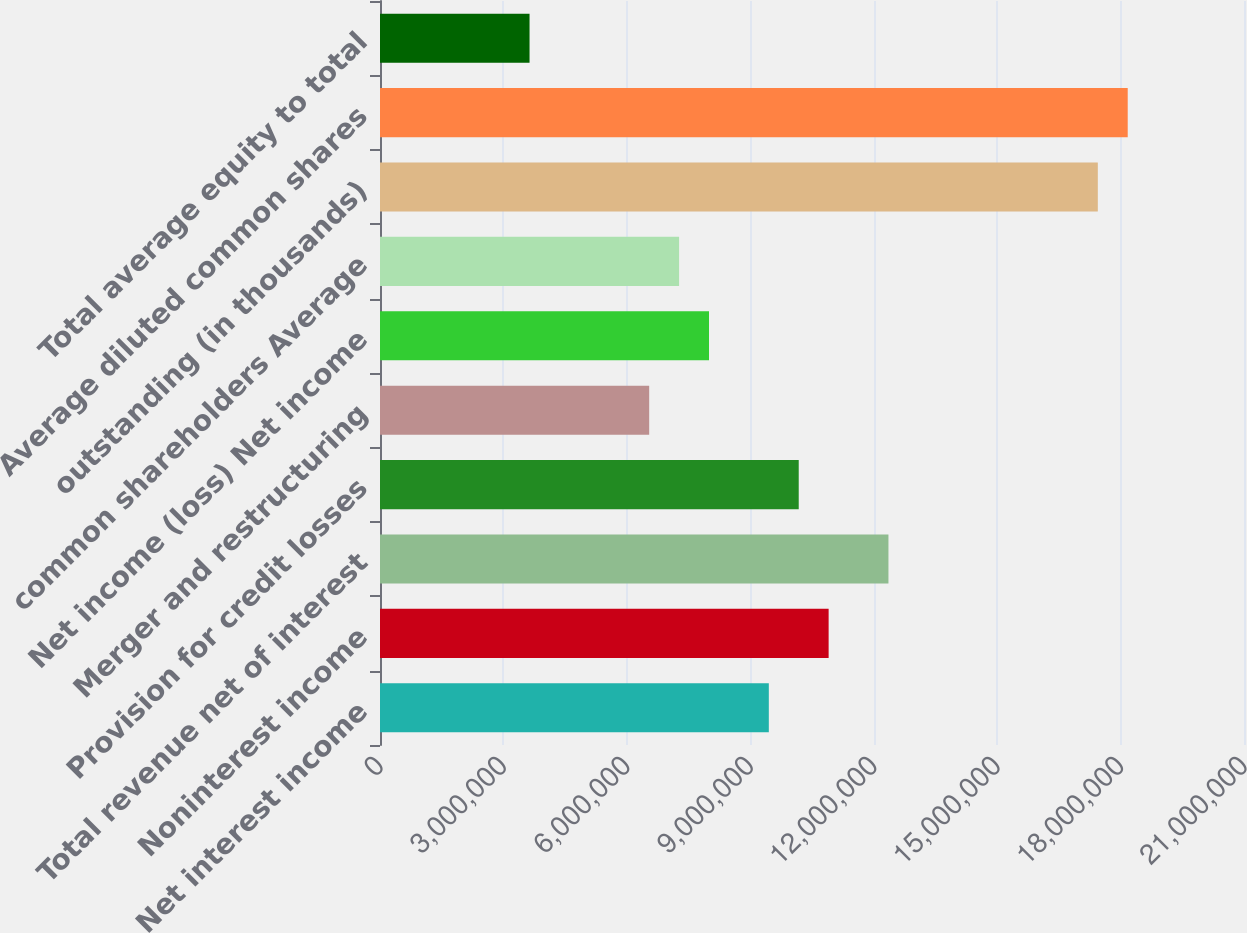<chart> <loc_0><loc_0><loc_500><loc_500><bar_chart><fcel>Net interest income<fcel>Noninterest income<fcel>Total revenue net of interest<fcel>Provision for credit losses<fcel>Merger and restructuring<fcel>Net income (loss) Net income<fcel>common shareholders Average<fcel>outstanding (in thousands)<fcel>Average diluted common shares<fcel>Total average equity to total<nl><fcel>9.45037e+06<fcel>1.09043e+07<fcel>1.23582e+07<fcel>1.01773e+07<fcel>6.54257e+06<fcel>7.99647e+06<fcel>7.26952e+06<fcel>1.74468e+07<fcel>1.81738e+07<fcel>3.63476e+06<nl></chart> 